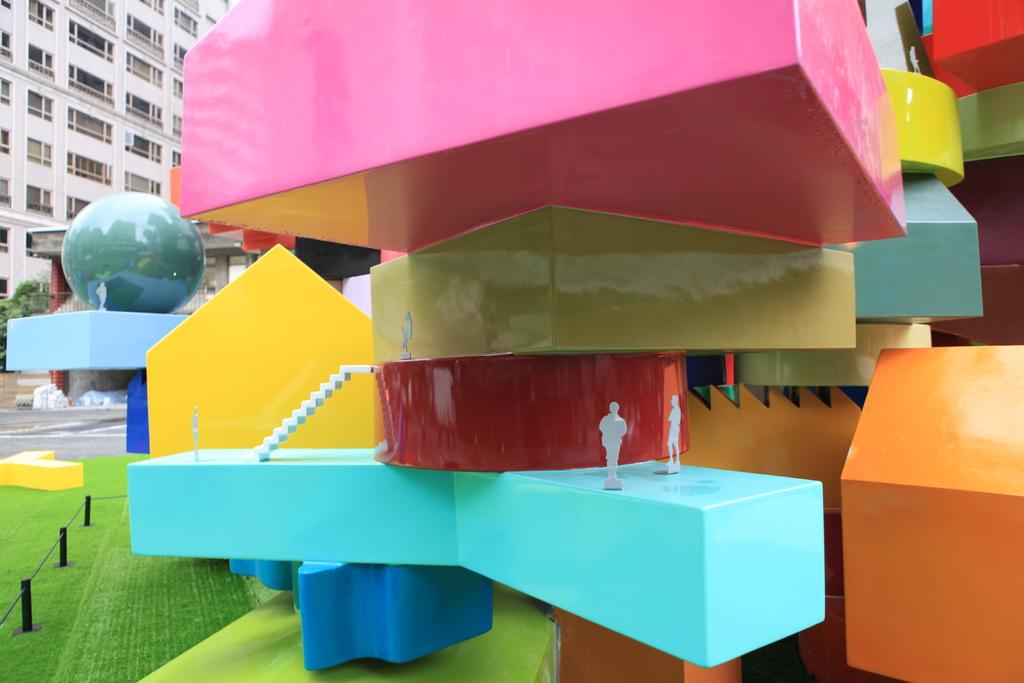What type of objects are present on the floor in the image? There are colourful blocks on the floor in the image. Can you describe the blocks in the image? The blocks are colourful, indicating they may be used for play or building. What can be seen in the background of the image? There is a building visible in the background of the image. How many bulbs are connected to the blocks in the image? There are no bulbs connected to the blocks in the image; the blocks are simply colourful objects on the floor. 